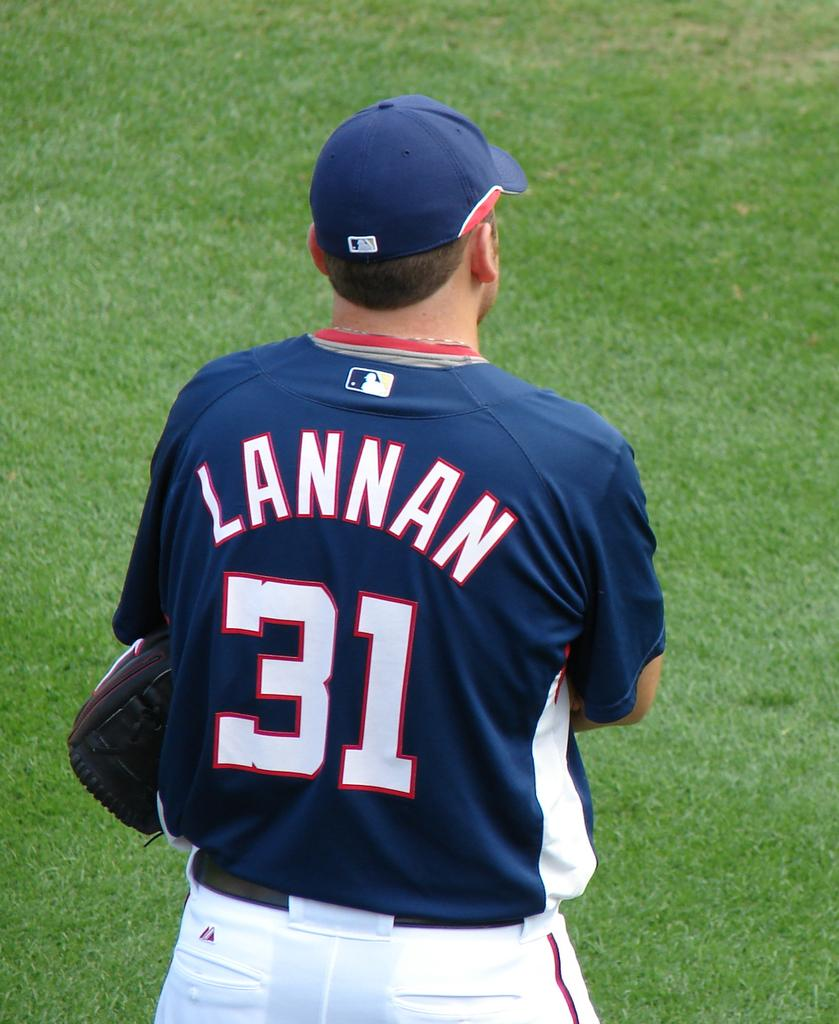<image>
Describe the image concisely. A  sportsman wearing a shirt reading Lannan 31. 